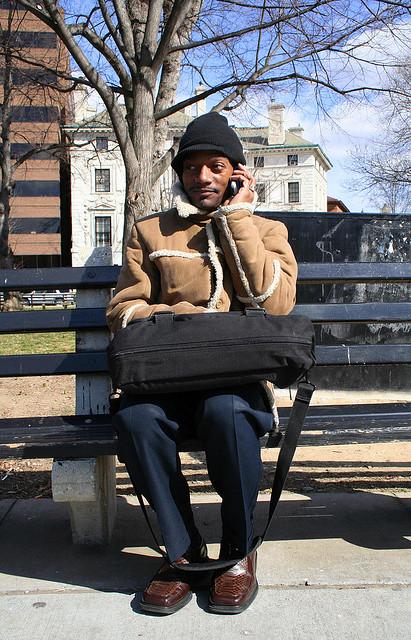What color is the bench?
Keep it brief. Black. What is in the man's lap?
Quick response, please. Bag. What is this person sitting on?
Quick response, please. Bench. 